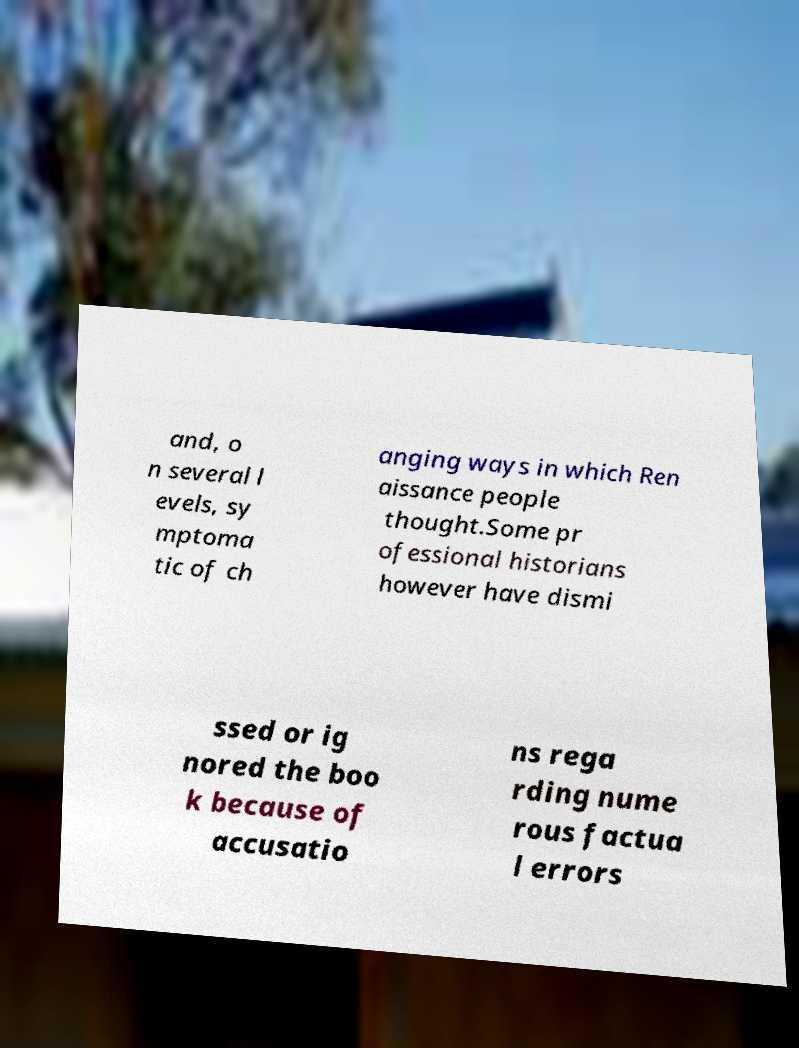Can you accurately transcribe the text from the provided image for me? and, o n several l evels, sy mptoma tic of ch anging ways in which Ren aissance people thought.Some pr ofessional historians however have dismi ssed or ig nored the boo k because of accusatio ns rega rding nume rous factua l errors 